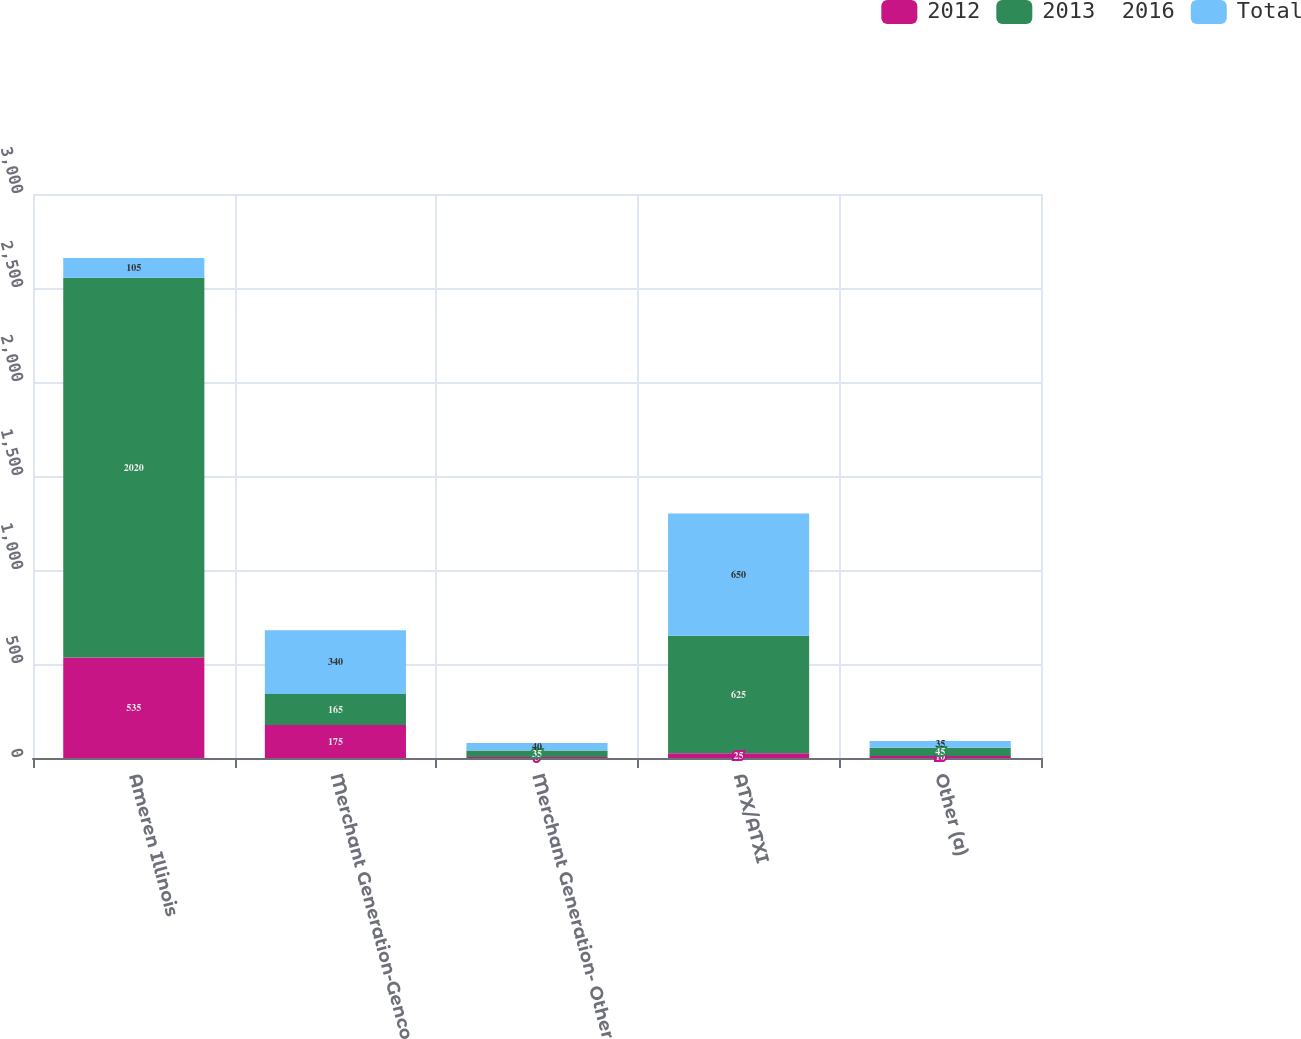<chart> <loc_0><loc_0><loc_500><loc_500><stacked_bar_chart><ecel><fcel>Ameren Illinois<fcel>Merchant Generation-Genco<fcel>Merchant Generation- Other<fcel>ATX/ATXI<fcel>Other (a)<nl><fcel>2012<fcel>535<fcel>175<fcel>5<fcel>25<fcel>10<nl><fcel>2013  2016<fcel>2020<fcel>165<fcel>35<fcel>625<fcel>45<nl><fcel>Total<fcel>105<fcel>340<fcel>40<fcel>650<fcel>35<nl></chart> 